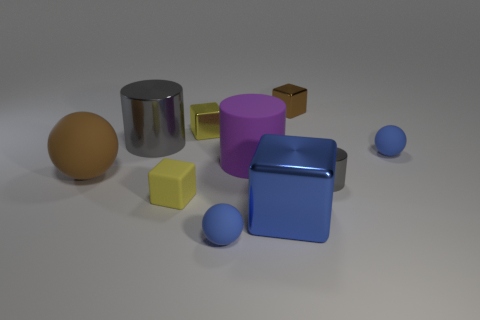Subtract all gray balls. How many yellow cubes are left? 2 Subtract all small blue rubber spheres. How many spheres are left? 1 Subtract all green blocks. Subtract all blue cylinders. How many blocks are left? 4 Subtract all cylinders. How many objects are left? 7 Subtract all blue balls. Subtract all tiny cubes. How many objects are left? 5 Add 3 small brown metallic things. How many small brown metallic things are left? 4 Add 7 big blue metal cubes. How many big blue metal cubes exist? 8 Subtract 0 brown cylinders. How many objects are left? 10 